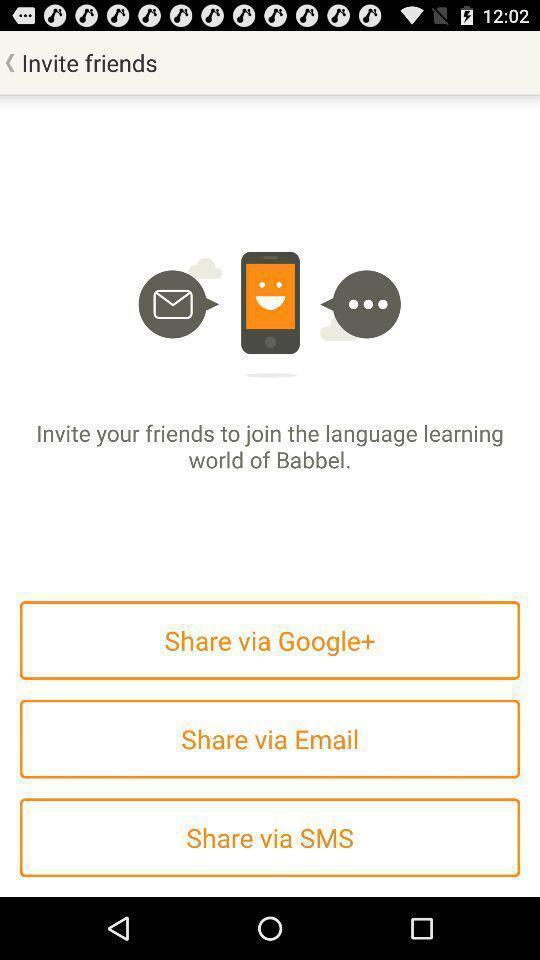Explain what's happening in this screen capture. Page to invite friends with application options. 